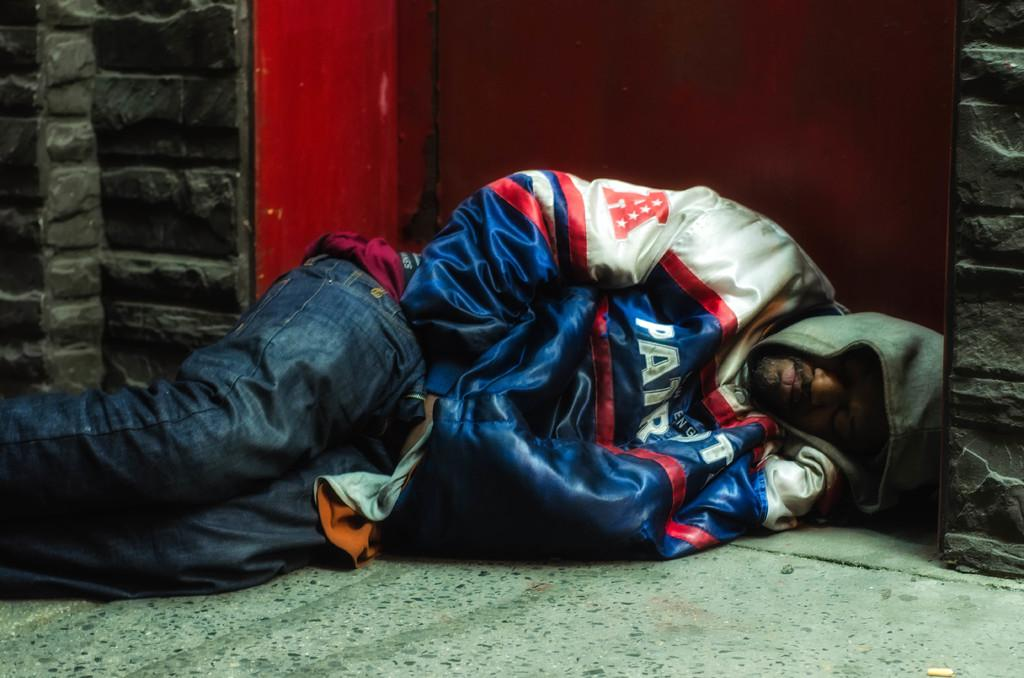What is the main subject of the image? There is a person in the image. What is the person doing in the image? The person is laying on the ground. What type of clothing is the person wearing? The person is wearing a jacket. What type of donkey can be seen in the image? There is no donkey present in the image. How many tomatoes are visible in the image? There are no tomatoes present in the image. 